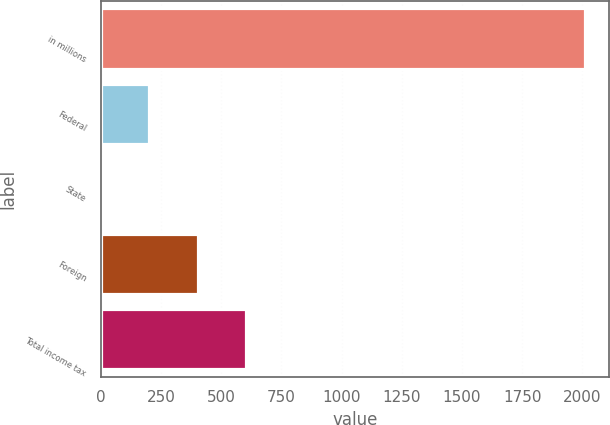Convert chart. <chart><loc_0><loc_0><loc_500><loc_500><bar_chart><fcel>in millions<fcel>Federal<fcel>State<fcel>Foreign<fcel>Total income tax<nl><fcel>2009<fcel>202.16<fcel>1.4<fcel>402.92<fcel>603.68<nl></chart> 